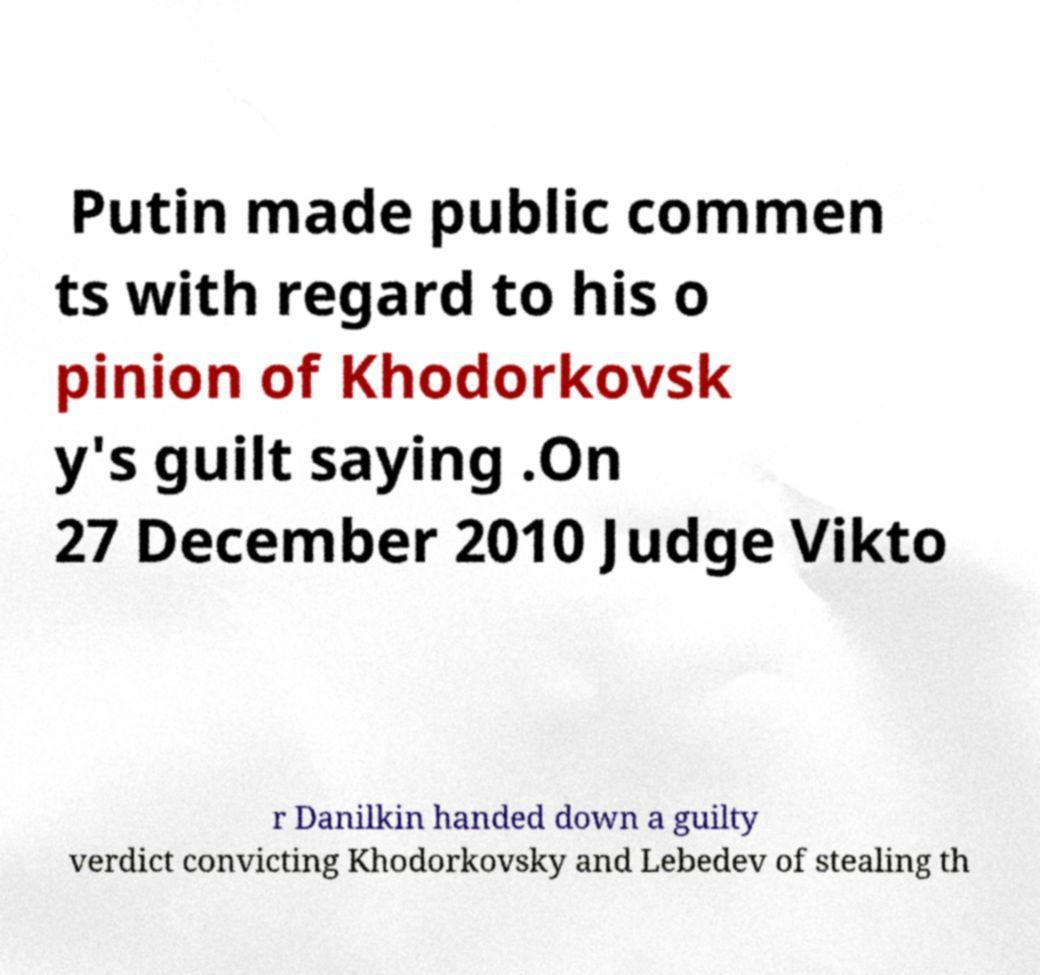What messages or text are displayed in this image? I need them in a readable, typed format. Putin made public commen ts with regard to his o pinion of Khodorkovsk y's guilt saying .On 27 December 2010 Judge Vikto r Danilkin handed down a guilty verdict convicting Khodorkovsky and Lebedev of stealing th 